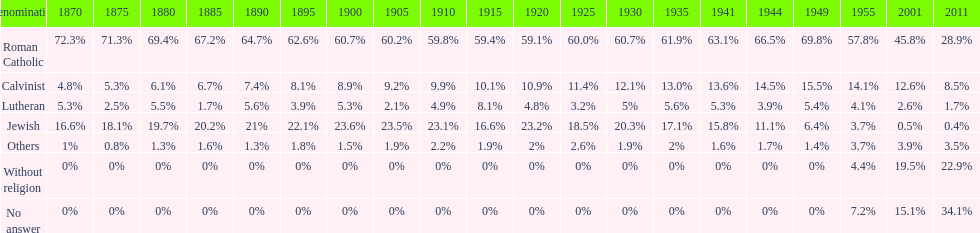How many denominations never dropped below 20%? 1. 